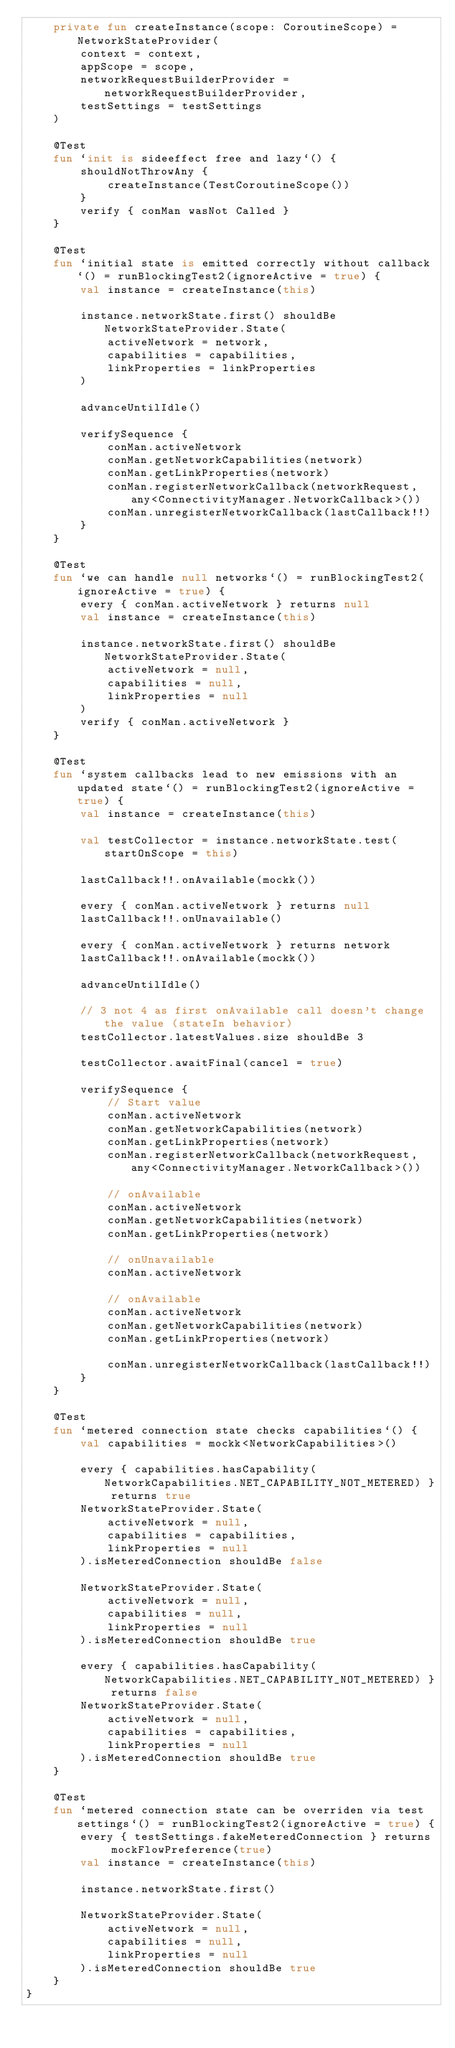<code> <loc_0><loc_0><loc_500><loc_500><_Kotlin_>    private fun createInstance(scope: CoroutineScope) = NetworkStateProvider(
        context = context,
        appScope = scope,
        networkRequestBuilderProvider = networkRequestBuilderProvider,
        testSettings = testSettings
    )

    @Test
    fun `init is sideeffect free and lazy`() {
        shouldNotThrowAny {
            createInstance(TestCoroutineScope())
        }
        verify { conMan wasNot Called }
    }

    @Test
    fun `initial state is emitted correctly without callback`() = runBlockingTest2(ignoreActive = true) {
        val instance = createInstance(this)

        instance.networkState.first() shouldBe NetworkStateProvider.State(
            activeNetwork = network,
            capabilities = capabilities,
            linkProperties = linkProperties
        )

        advanceUntilIdle()

        verifySequence {
            conMan.activeNetwork
            conMan.getNetworkCapabilities(network)
            conMan.getLinkProperties(network)
            conMan.registerNetworkCallback(networkRequest, any<ConnectivityManager.NetworkCallback>())
            conMan.unregisterNetworkCallback(lastCallback!!)
        }
    }

    @Test
    fun `we can handle null networks`() = runBlockingTest2(ignoreActive = true) {
        every { conMan.activeNetwork } returns null
        val instance = createInstance(this)

        instance.networkState.first() shouldBe NetworkStateProvider.State(
            activeNetwork = null,
            capabilities = null,
            linkProperties = null
        )
        verify { conMan.activeNetwork }
    }

    @Test
    fun `system callbacks lead to new emissions with an updated state`() = runBlockingTest2(ignoreActive = true) {
        val instance = createInstance(this)

        val testCollector = instance.networkState.test(startOnScope = this)

        lastCallback!!.onAvailable(mockk())

        every { conMan.activeNetwork } returns null
        lastCallback!!.onUnavailable()

        every { conMan.activeNetwork } returns network
        lastCallback!!.onAvailable(mockk())

        advanceUntilIdle()

        // 3 not 4 as first onAvailable call doesn't change the value (stateIn behavior)
        testCollector.latestValues.size shouldBe 3

        testCollector.awaitFinal(cancel = true)

        verifySequence {
            // Start value
            conMan.activeNetwork
            conMan.getNetworkCapabilities(network)
            conMan.getLinkProperties(network)
            conMan.registerNetworkCallback(networkRequest, any<ConnectivityManager.NetworkCallback>())

            // onAvailable
            conMan.activeNetwork
            conMan.getNetworkCapabilities(network)
            conMan.getLinkProperties(network)

            // onUnavailable
            conMan.activeNetwork

            // onAvailable
            conMan.activeNetwork
            conMan.getNetworkCapabilities(network)
            conMan.getLinkProperties(network)

            conMan.unregisterNetworkCallback(lastCallback!!)
        }
    }

    @Test
    fun `metered connection state checks capabilities`() {
        val capabilities = mockk<NetworkCapabilities>()

        every { capabilities.hasCapability(NetworkCapabilities.NET_CAPABILITY_NOT_METERED) } returns true
        NetworkStateProvider.State(
            activeNetwork = null,
            capabilities = capabilities,
            linkProperties = null
        ).isMeteredConnection shouldBe false

        NetworkStateProvider.State(
            activeNetwork = null,
            capabilities = null,
            linkProperties = null
        ).isMeteredConnection shouldBe true

        every { capabilities.hasCapability(NetworkCapabilities.NET_CAPABILITY_NOT_METERED) } returns false
        NetworkStateProvider.State(
            activeNetwork = null,
            capabilities = capabilities,
            linkProperties = null
        ).isMeteredConnection shouldBe true
    }

    @Test
    fun `metered connection state can be overriden via test settings`() = runBlockingTest2(ignoreActive = true) {
        every { testSettings.fakeMeteredConnection } returns mockFlowPreference(true)
        val instance = createInstance(this)

        instance.networkState.first()

        NetworkStateProvider.State(
            activeNetwork = null,
            capabilities = null,
            linkProperties = null
        ).isMeteredConnection shouldBe true
    }
}
</code> 